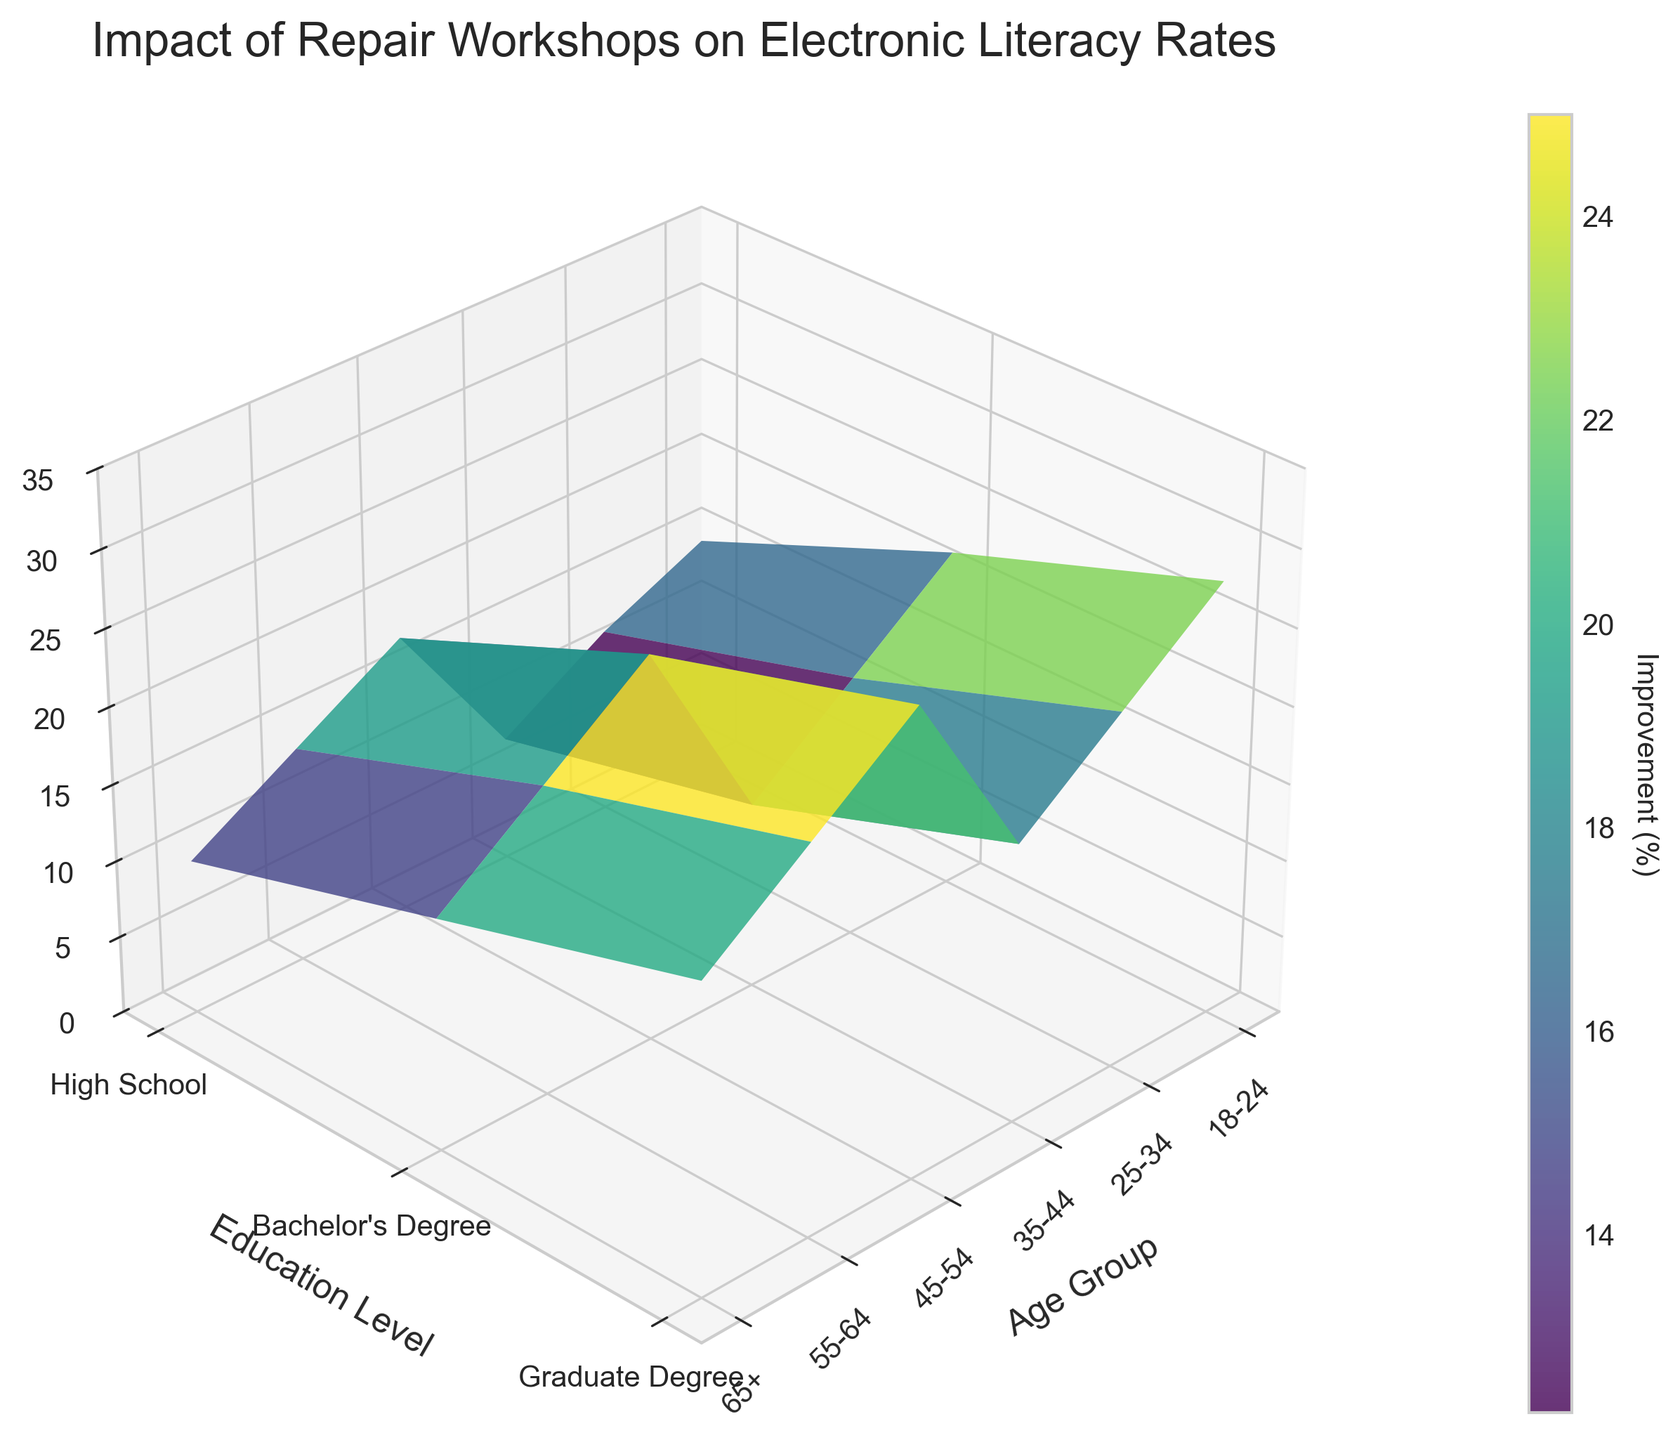What is the title of the 3D surface plot? The title is located at the top center of the plot and it reads "Impact of Repair Workshops on Electronic Literacy Rates".
Answer: Impact of Repair Workshops on Electronic Literacy Rates Which age group is represented on the far left of the x-axis? The x-axis, labeled "Age Group", has the first tick representing the age group '18-24' on the far left.
Answer: 18-24 What is the range of the Z-axis? The Z-axis is labeled "Electronic Literacy Rate Improvement (%)" and has values ranging from 0 to 35.
Answer: 0 to 35 Which education level shows the highest improvement in electronic literacy for age group 65+? By examining the highest point on the surface plot for age group 65+ along the education levels, High School shows the highest improvement with 30%.
Answer: High School How does the electronic literacy rate improvement for "25-34" age group with a "Bachelor's Degree" compare to those with a "Graduate Degree"? For the age group 25-34, Bachelor's Degree shows an improvement of 14%, while Graduate Degree shows 10%. Comparing them, those with a Bachelor's Degree have a higher improvement by 4%.
Answer: Bachelor's Degrees show higher improvement by 4% What trend do you observe in the improvement rates across different education levels for the "55-64" age group? Observing the surface plot for the 55-64 age group, the improvement rates decrease as education level increases from High School (28%) to Bachelor's Degree (23%) to Graduate Degree (18%).
Answer: Decreasing trend with higher education Compare the overall trend of electronic literacy rate improvement for different age groups with High School education. Across different age groups with High School education, the rates generally increase from younger (18-24 at 15%) to older (65+ at 30%) age groups.
Answer: Increasing trend with age Which age group and education level combination leads to the minimum improvement in electronic literacy rates? The minimum improvement rate can be found at age group 18-24 with Graduate Degree, showing an improvement of 8%.
Answer: 18-24 Graduate Degree What is the general pattern of electronic literacy rate improvement as the age group increases, regardless of education level? The surface plot demonstrates that as the age group increases, the electronic literacy rate improvement tends to rise for all education levels.
Answer: Increasing trend with age 